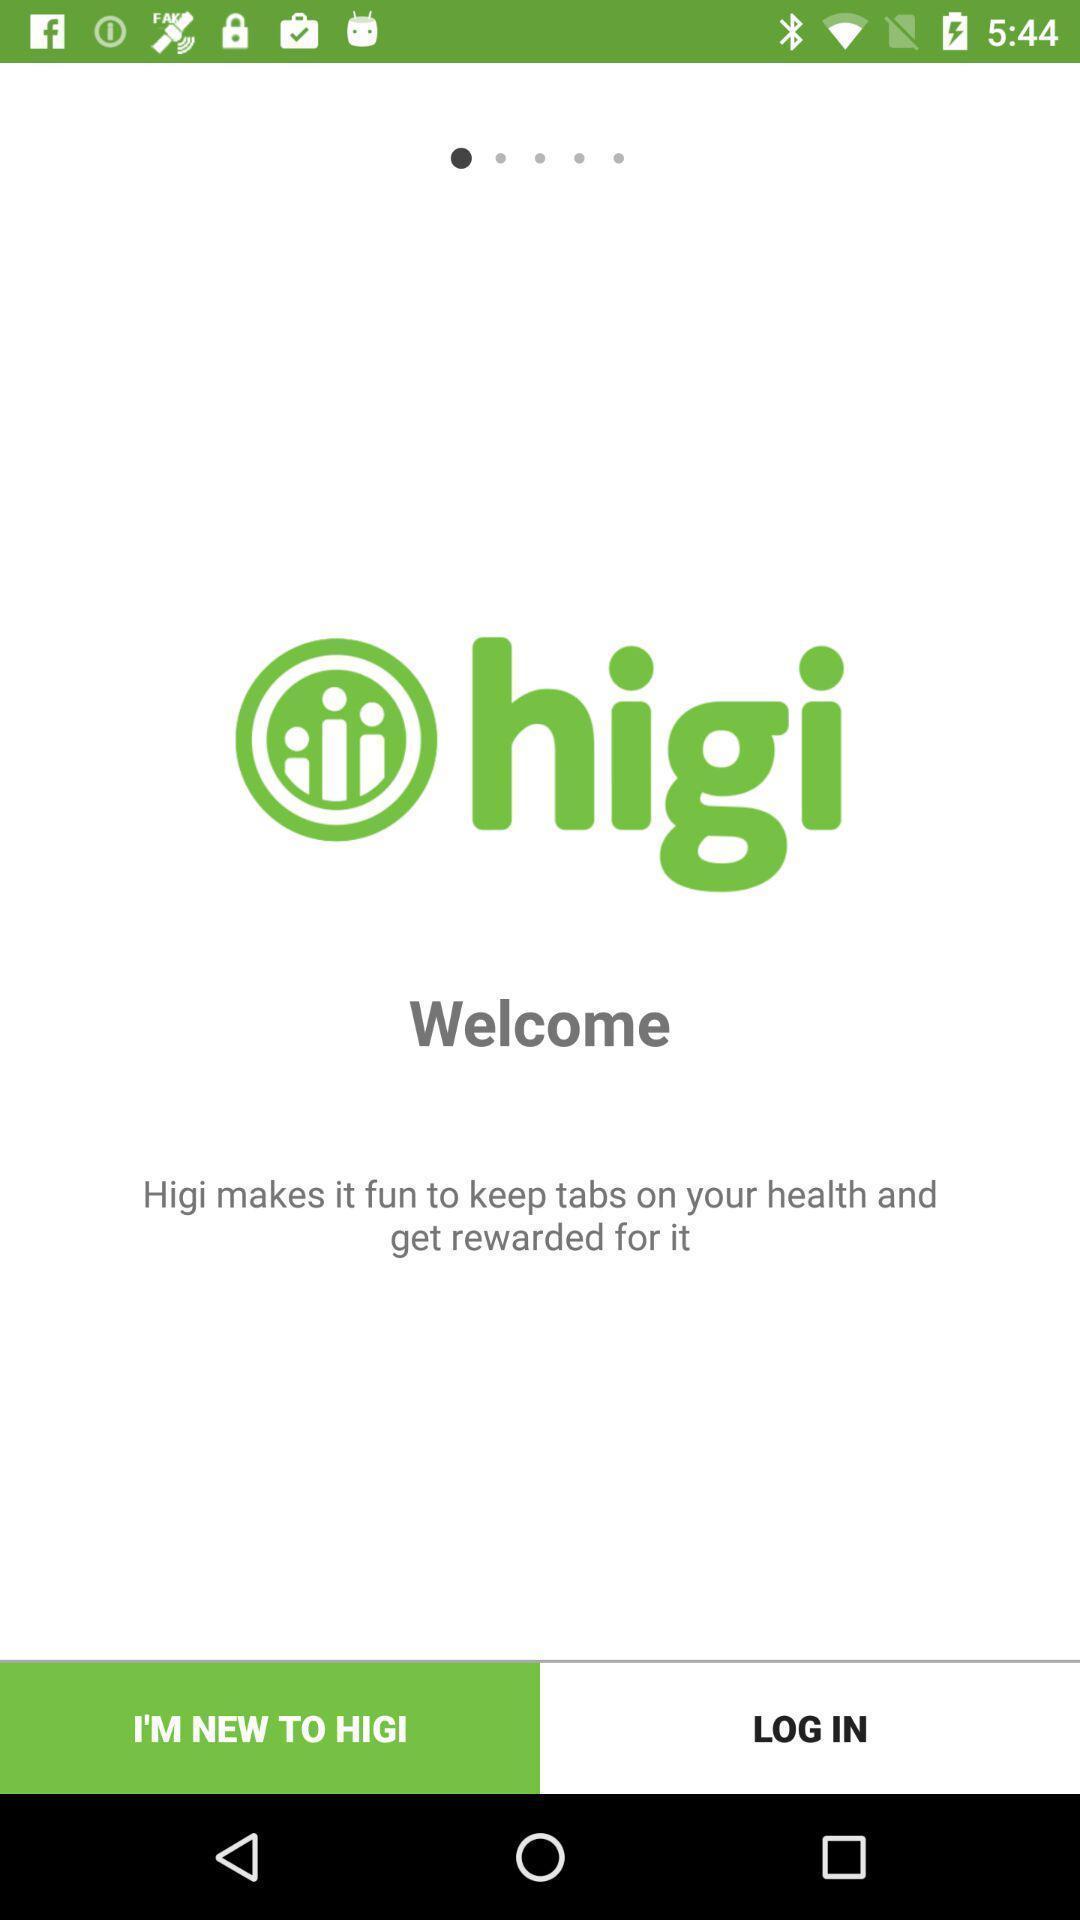Tell me about the visual elements in this screen capture. Welcome page or log in. 